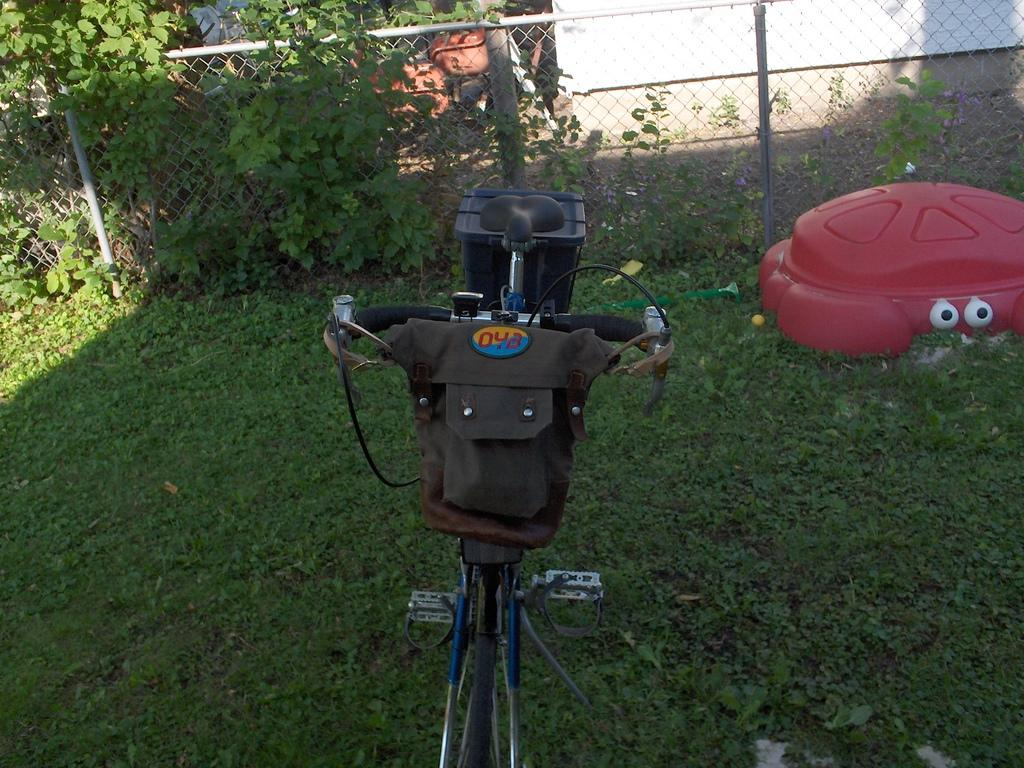What type of vegetation is present in the image? The image contains grass. What object is placed on the grass? There is a bicycle on the grass. What other item can be seen on the grass? A tube is placed on the grass. What architectural feature is visible in the image? There is a fence visible in the image. What color is the wall in the image? There is a white-colored wall in the image. What type of zipper can be seen on the grandmother's dress in the image? There is no grandmother or dress present in the image, so there is no zipper to be seen. 